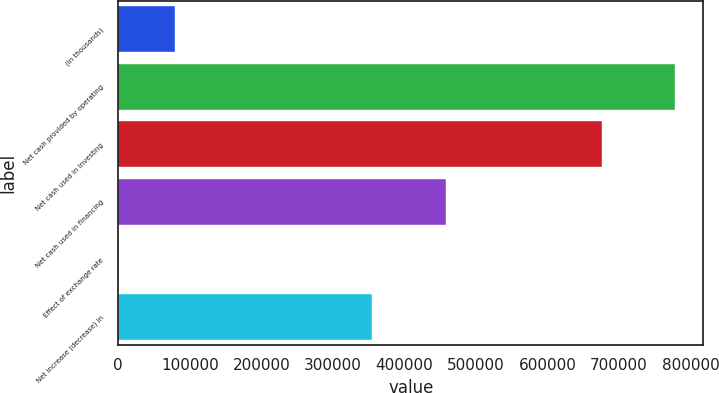Convert chart to OTSL. <chart><loc_0><loc_0><loc_500><loc_500><bar_chart><fcel>(In thousands)<fcel>Net cash provided by operating<fcel>Net cash used in investing<fcel>Net cash used in financing<fcel>Effect of exchange rate<fcel>Net increase (decrease) in<nl><fcel>79311.5<fcel>778886<fcel>676109<fcel>458887<fcel>1581<fcel>354529<nl></chart> 